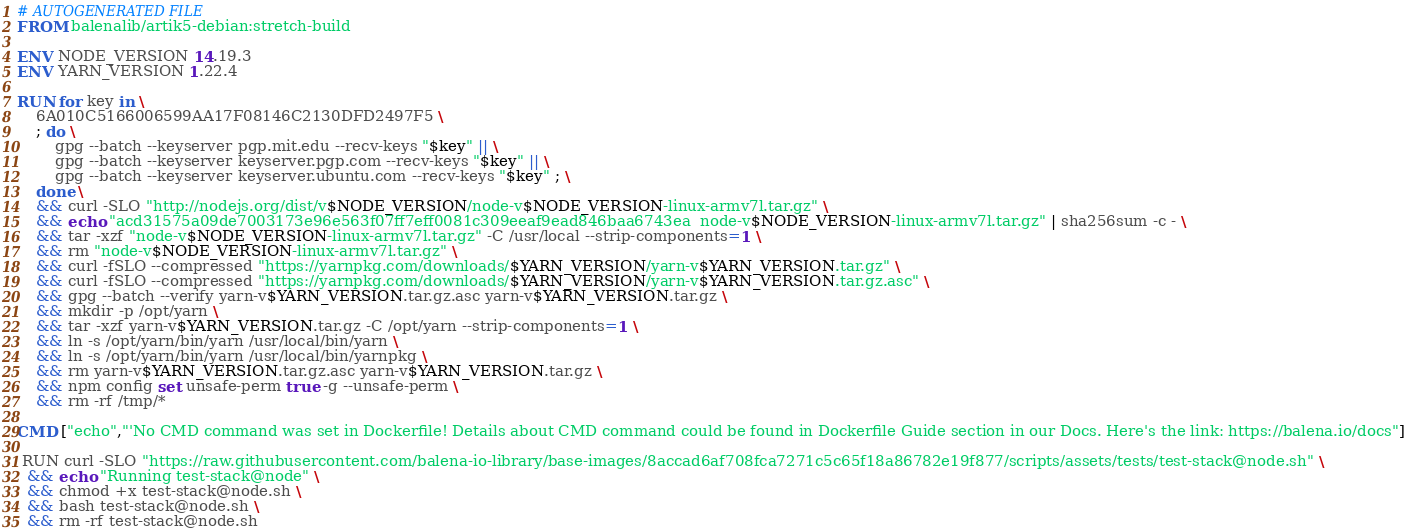Convert code to text. <code><loc_0><loc_0><loc_500><loc_500><_Dockerfile_># AUTOGENERATED FILE
FROM balenalib/artik5-debian:stretch-build

ENV NODE_VERSION 14.19.3
ENV YARN_VERSION 1.22.4

RUN for key in \
	6A010C5166006599AA17F08146C2130DFD2497F5 \
	; do \
		gpg --batch --keyserver pgp.mit.edu --recv-keys "$key" || \
		gpg --batch --keyserver keyserver.pgp.com --recv-keys "$key" || \
		gpg --batch --keyserver keyserver.ubuntu.com --recv-keys "$key" ; \
	done \
	&& curl -SLO "http://nodejs.org/dist/v$NODE_VERSION/node-v$NODE_VERSION-linux-armv7l.tar.gz" \
	&& echo "acd31575a09de7003173e96e563f07ff7eff0081c309eeaf9ead846baa6743ea  node-v$NODE_VERSION-linux-armv7l.tar.gz" | sha256sum -c - \
	&& tar -xzf "node-v$NODE_VERSION-linux-armv7l.tar.gz" -C /usr/local --strip-components=1 \
	&& rm "node-v$NODE_VERSION-linux-armv7l.tar.gz" \
	&& curl -fSLO --compressed "https://yarnpkg.com/downloads/$YARN_VERSION/yarn-v$YARN_VERSION.tar.gz" \
	&& curl -fSLO --compressed "https://yarnpkg.com/downloads/$YARN_VERSION/yarn-v$YARN_VERSION.tar.gz.asc" \
	&& gpg --batch --verify yarn-v$YARN_VERSION.tar.gz.asc yarn-v$YARN_VERSION.tar.gz \
	&& mkdir -p /opt/yarn \
	&& tar -xzf yarn-v$YARN_VERSION.tar.gz -C /opt/yarn --strip-components=1 \
	&& ln -s /opt/yarn/bin/yarn /usr/local/bin/yarn \
	&& ln -s /opt/yarn/bin/yarn /usr/local/bin/yarnpkg \
	&& rm yarn-v$YARN_VERSION.tar.gz.asc yarn-v$YARN_VERSION.tar.gz \
	&& npm config set unsafe-perm true -g --unsafe-perm \
	&& rm -rf /tmp/*

CMD ["echo","'No CMD command was set in Dockerfile! Details about CMD command could be found in Dockerfile Guide section in our Docs. Here's the link: https://balena.io/docs"]

 RUN curl -SLO "https://raw.githubusercontent.com/balena-io-library/base-images/8accad6af708fca7271c5c65f18a86782e19f877/scripts/assets/tests/test-stack@node.sh" \
  && echo "Running test-stack@node" \
  && chmod +x test-stack@node.sh \
  && bash test-stack@node.sh \
  && rm -rf test-stack@node.sh 
</code> 